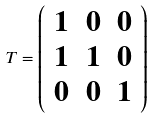<formula> <loc_0><loc_0><loc_500><loc_500>T = \left ( \begin{array} { c c c } 1 & 0 & 0 \\ 1 & 1 & 0 \\ 0 & 0 & 1 \end{array} \right )</formula> 